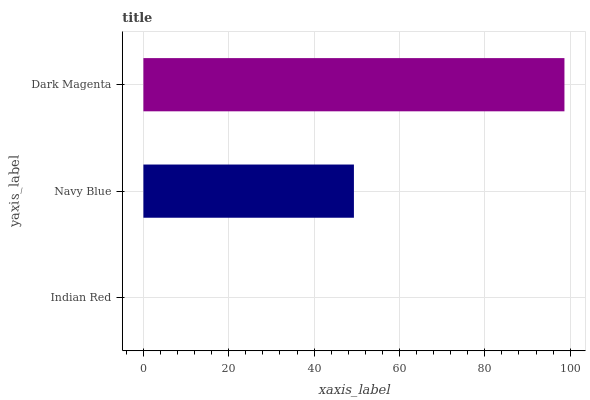Is Indian Red the minimum?
Answer yes or no. Yes. Is Dark Magenta the maximum?
Answer yes or no. Yes. Is Navy Blue the minimum?
Answer yes or no. No. Is Navy Blue the maximum?
Answer yes or no. No. Is Navy Blue greater than Indian Red?
Answer yes or no. Yes. Is Indian Red less than Navy Blue?
Answer yes or no. Yes. Is Indian Red greater than Navy Blue?
Answer yes or no. No. Is Navy Blue less than Indian Red?
Answer yes or no. No. Is Navy Blue the high median?
Answer yes or no. Yes. Is Navy Blue the low median?
Answer yes or no. Yes. Is Indian Red the high median?
Answer yes or no. No. Is Indian Red the low median?
Answer yes or no. No. 